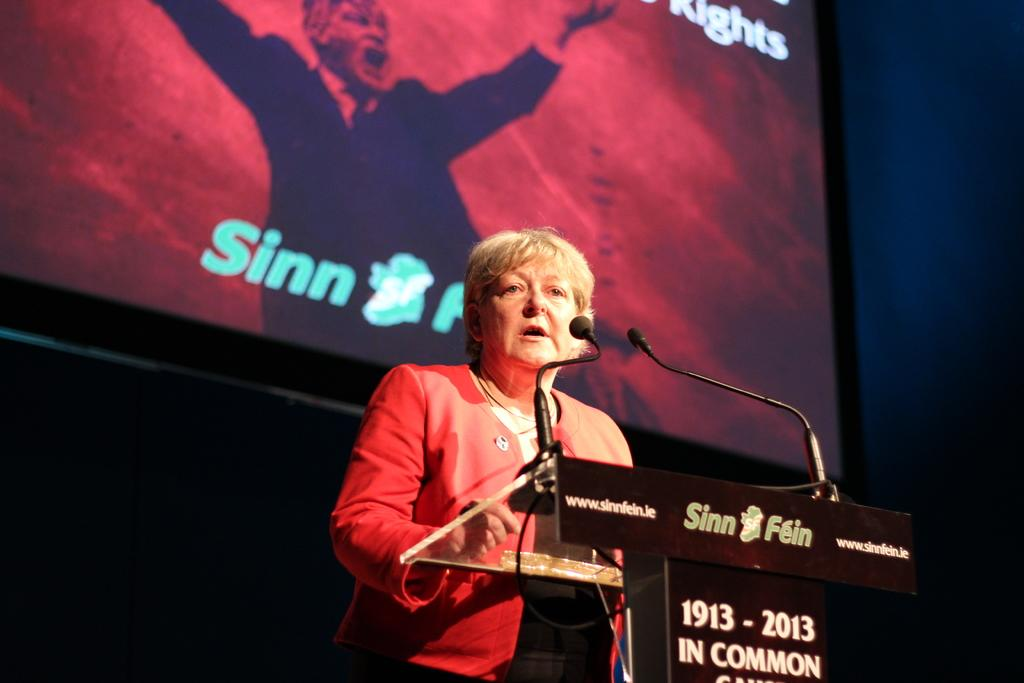Provide a one-sentence caption for the provided image. A woman standing in front of a podium reading 1913-2013. 